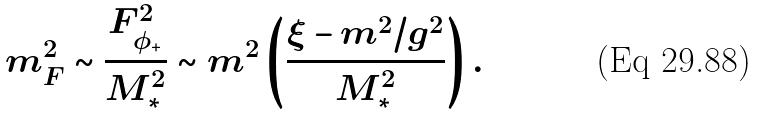Convert formula to latex. <formula><loc_0><loc_0><loc_500><loc_500>m _ { F } ^ { 2 } \sim \frac { F _ { \phi _ { + } } ^ { 2 } } { M _ { * } ^ { 2 } } \sim m ^ { 2 } \left ( \frac { \xi - m ^ { 2 } / g ^ { 2 } } { M _ { * } ^ { 2 } } \right ) .</formula> 